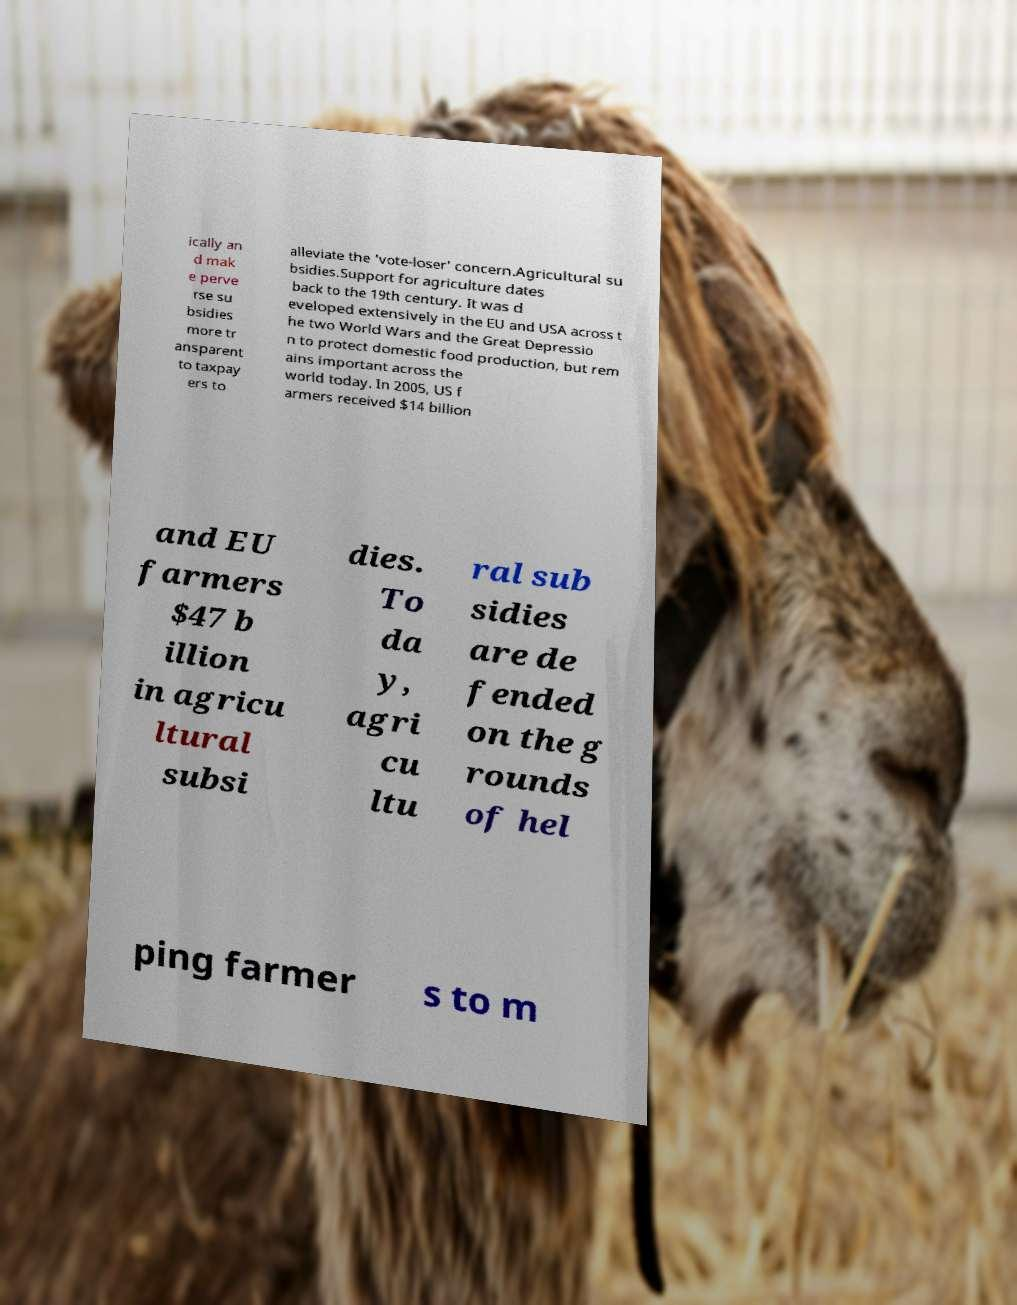There's text embedded in this image that I need extracted. Can you transcribe it verbatim? ically an d mak e perve rse su bsidies more tr ansparent to taxpay ers to alleviate the 'vote-loser' concern.Agricultural su bsidies.Support for agriculture dates back to the 19th century. It was d eveloped extensively in the EU and USA across t he two World Wars and the Great Depressio n to protect domestic food production, but rem ains important across the world today. In 2005, US f armers received $14 billion and EU farmers $47 b illion in agricu ltural subsi dies. To da y, agri cu ltu ral sub sidies are de fended on the g rounds of hel ping farmer s to m 